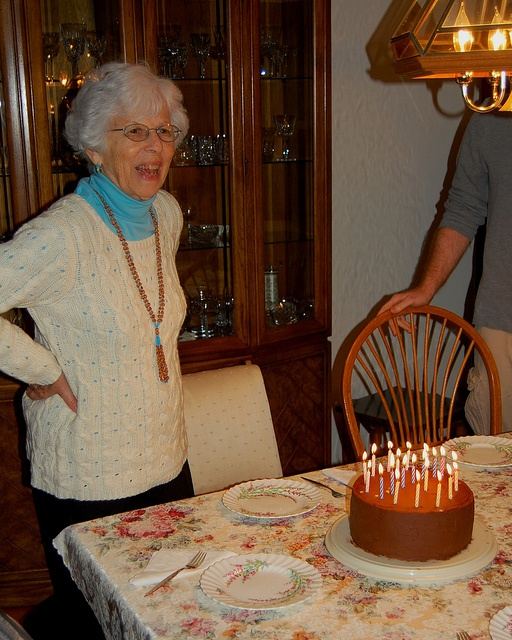Describe the objects in this image and their specific colors. I can see people in maroon, tan, black, and gray tones, dining table in maroon, tan, and gray tones, chair in maroon, black, and gray tones, people in maroon, black, and brown tones, and cake in maroon, brown, and tan tones in this image. 